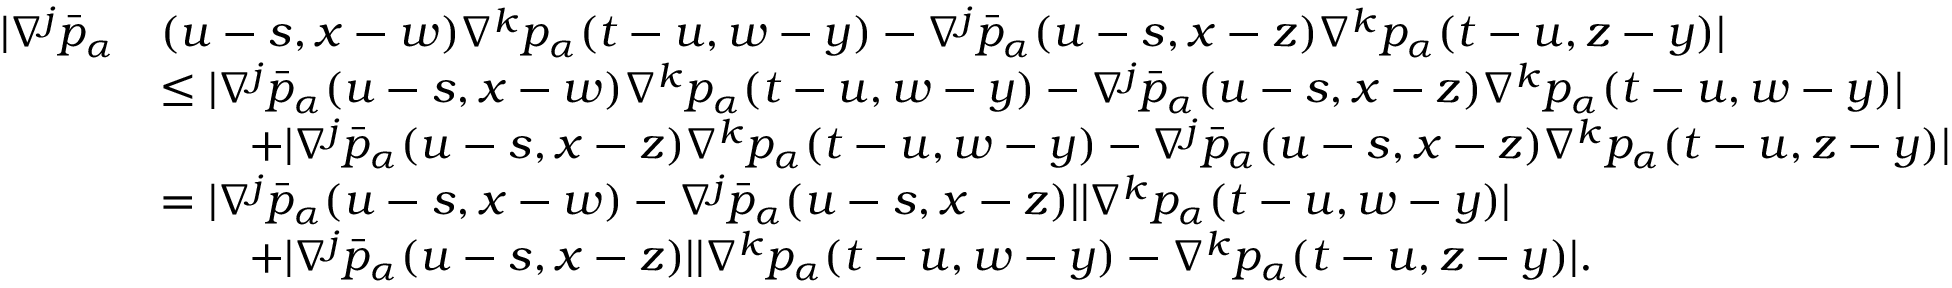<formula> <loc_0><loc_0><loc_500><loc_500>\begin{array} { r l } { | \nabla ^ { j } \bar { p } _ { \alpha } } & { ( u - s , x - w ) \nabla ^ { k } p _ { \alpha } ( t - u , w - y ) - \nabla ^ { j } \bar { p } _ { \alpha } ( u - s , x - z ) \nabla ^ { k } p _ { \alpha } ( t - u , z - y ) | } \\ & { \leq | \nabla ^ { j } \bar { p } _ { \alpha } ( u - s , x - w ) \nabla ^ { k } p _ { \alpha } ( t - u , w - y ) - \nabla ^ { j } \bar { p } _ { \alpha } ( u - s , x - z ) \nabla ^ { k } p _ { \alpha } ( t - u , w - y ) | } \\ & { \quad + | \nabla ^ { j } \bar { p } _ { \alpha } ( u - s , x - z ) \nabla ^ { k } p _ { \alpha } ( t - u , w - y ) - \nabla ^ { j } \bar { p } _ { \alpha } ( u - s , x - z ) \nabla ^ { k } p _ { \alpha } ( t - u , z - y ) | } \\ & { = | \nabla ^ { j } \bar { p } _ { \alpha } ( u - s , x - w ) - \nabla ^ { j } \bar { p } _ { \alpha } ( u - s , x - z ) | | \nabla ^ { k } p _ { \alpha } ( t - u , w - y ) | } \\ & { \quad + | \nabla ^ { j } \bar { p } _ { \alpha } ( u - s , x - z ) | | \nabla ^ { k } p _ { \alpha } ( t - u , w - y ) - \nabla ^ { k } p _ { \alpha } ( t - u , z - y ) | . } \end{array}</formula> 